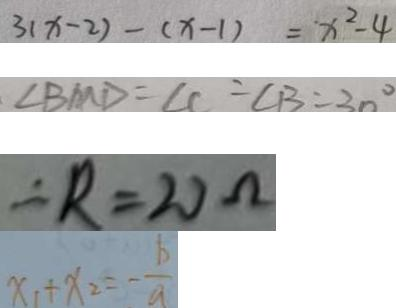Convert formula to latex. <formula><loc_0><loc_0><loc_500><loc_500>3 ( x - 2 ) - ( x - 1 ) = x ^ { 2 } - 4 
 . \angle B M D = \angle C = \angle B = 3 0 ^ { \circ } 
 \therefore R = 2 0 \Omega 
 x _ { 1 } + x _ { 2 } = - \frac { b } { a }</formula> 